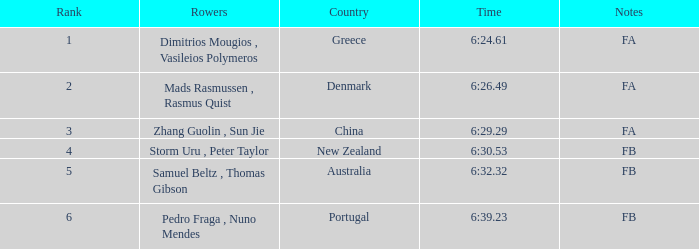32, and notations of fb? Australia. 